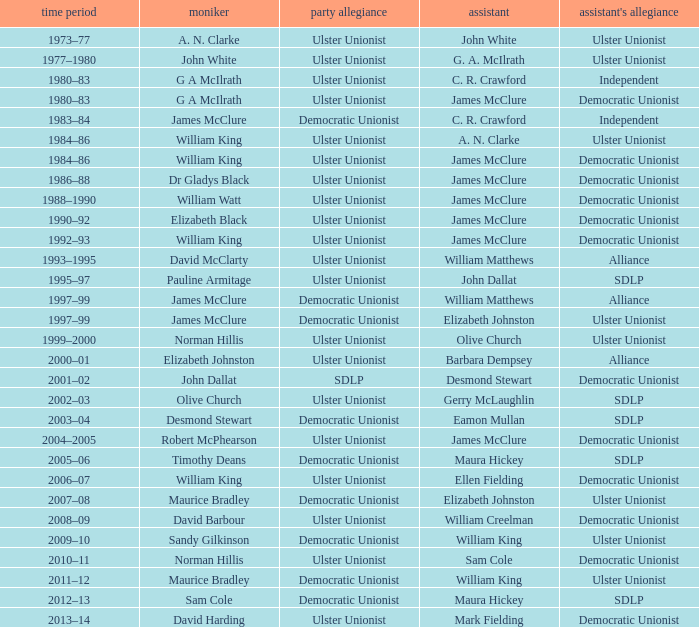What is the name of the deputy in 1992–93? James McClure. Can you give me this table as a dict? {'header': ['time period', 'moniker', 'party allegiance', 'assistant', "assistant's allegiance"], 'rows': [['1973–77', 'A. N. Clarke', 'Ulster Unionist', 'John White', 'Ulster Unionist'], ['1977–1980', 'John White', 'Ulster Unionist', 'G. A. McIlrath', 'Ulster Unionist'], ['1980–83', 'G A McIlrath', 'Ulster Unionist', 'C. R. Crawford', 'Independent'], ['1980–83', 'G A McIlrath', 'Ulster Unionist', 'James McClure', 'Democratic Unionist'], ['1983–84', 'James McClure', 'Democratic Unionist', 'C. R. Crawford', 'Independent'], ['1984–86', 'William King', 'Ulster Unionist', 'A. N. Clarke', 'Ulster Unionist'], ['1984–86', 'William King', 'Ulster Unionist', 'James McClure', 'Democratic Unionist'], ['1986–88', 'Dr Gladys Black', 'Ulster Unionist', 'James McClure', 'Democratic Unionist'], ['1988–1990', 'William Watt', 'Ulster Unionist', 'James McClure', 'Democratic Unionist'], ['1990–92', 'Elizabeth Black', 'Ulster Unionist', 'James McClure', 'Democratic Unionist'], ['1992–93', 'William King', 'Ulster Unionist', 'James McClure', 'Democratic Unionist'], ['1993–1995', 'David McClarty', 'Ulster Unionist', 'William Matthews', 'Alliance'], ['1995–97', 'Pauline Armitage', 'Ulster Unionist', 'John Dallat', 'SDLP'], ['1997–99', 'James McClure', 'Democratic Unionist', 'William Matthews', 'Alliance'], ['1997–99', 'James McClure', 'Democratic Unionist', 'Elizabeth Johnston', 'Ulster Unionist'], ['1999–2000', 'Norman Hillis', 'Ulster Unionist', 'Olive Church', 'Ulster Unionist'], ['2000–01', 'Elizabeth Johnston', 'Ulster Unionist', 'Barbara Dempsey', 'Alliance'], ['2001–02', 'John Dallat', 'SDLP', 'Desmond Stewart', 'Democratic Unionist'], ['2002–03', 'Olive Church', 'Ulster Unionist', 'Gerry McLaughlin', 'SDLP'], ['2003–04', 'Desmond Stewart', 'Democratic Unionist', 'Eamon Mullan', 'SDLP'], ['2004–2005', 'Robert McPhearson', 'Ulster Unionist', 'James McClure', 'Democratic Unionist'], ['2005–06', 'Timothy Deans', 'Democratic Unionist', 'Maura Hickey', 'SDLP'], ['2006–07', 'William King', 'Ulster Unionist', 'Ellen Fielding', 'Democratic Unionist'], ['2007–08', 'Maurice Bradley', 'Democratic Unionist', 'Elizabeth Johnston', 'Ulster Unionist'], ['2008–09', 'David Barbour', 'Ulster Unionist', 'William Creelman', 'Democratic Unionist'], ['2009–10', 'Sandy Gilkinson', 'Democratic Unionist', 'William King', 'Ulster Unionist'], ['2010–11', 'Norman Hillis', 'Ulster Unionist', 'Sam Cole', 'Democratic Unionist'], ['2011–12', 'Maurice Bradley', 'Democratic Unionist', 'William King', 'Ulster Unionist'], ['2012–13', 'Sam Cole', 'Democratic Unionist', 'Maura Hickey', 'SDLP'], ['2013–14', 'David Harding', 'Ulster Unionist', 'Mark Fielding', 'Democratic Unionist']]} 